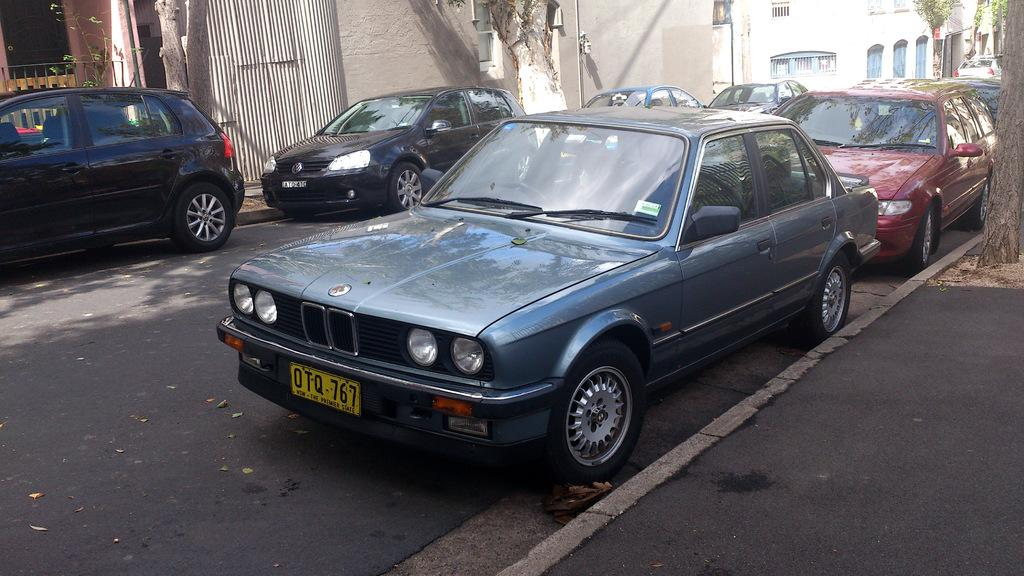What can be seen on the road in the image? There are cars on the road in the image. What is visible in the background of the image? There is a building, a wall, and trees in the background of the image. Where is the scarecrow standing in the image? There is no scarecrow present in the image. What type of soap is being used to clean the cars in the image? There is no soap or car-cleaning activity depicted in the image. 